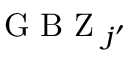Convert formula to latex. <formula><loc_0><loc_0><loc_500><loc_500>G B Z _ { j ^ { \prime } }</formula> 